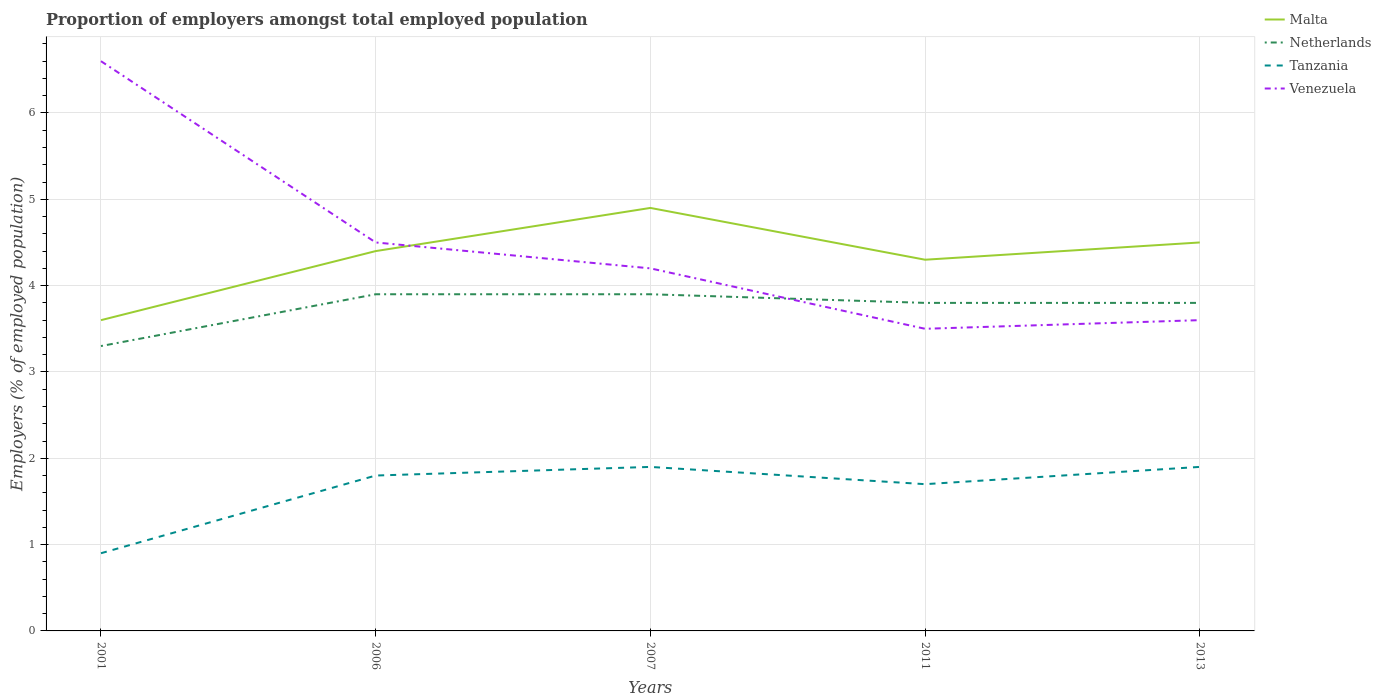How many different coloured lines are there?
Give a very brief answer. 4. Does the line corresponding to Netherlands intersect with the line corresponding to Venezuela?
Your answer should be compact. Yes. Is the number of lines equal to the number of legend labels?
Give a very brief answer. Yes. Across all years, what is the maximum proportion of employers in Malta?
Your response must be concise. 3.6. In which year was the proportion of employers in Netherlands maximum?
Give a very brief answer. 2001. What is the total proportion of employers in Netherlands in the graph?
Your response must be concise. 0.1. What is the difference between the highest and the second highest proportion of employers in Malta?
Make the answer very short. 1.3. What is the difference between the highest and the lowest proportion of employers in Malta?
Your response must be concise. 3. Is the proportion of employers in Tanzania strictly greater than the proportion of employers in Netherlands over the years?
Offer a very short reply. Yes. How many lines are there?
Your answer should be very brief. 4. What is the difference between two consecutive major ticks on the Y-axis?
Your answer should be compact. 1. Does the graph contain any zero values?
Offer a terse response. No. Does the graph contain grids?
Your answer should be compact. Yes. How many legend labels are there?
Ensure brevity in your answer.  4. How are the legend labels stacked?
Your answer should be compact. Vertical. What is the title of the graph?
Give a very brief answer. Proportion of employers amongst total employed population. What is the label or title of the Y-axis?
Offer a terse response. Employers (% of employed population). What is the Employers (% of employed population) of Malta in 2001?
Ensure brevity in your answer.  3.6. What is the Employers (% of employed population) of Netherlands in 2001?
Provide a succinct answer. 3.3. What is the Employers (% of employed population) of Tanzania in 2001?
Keep it short and to the point. 0.9. What is the Employers (% of employed population) of Venezuela in 2001?
Ensure brevity in your answer.  6.6. What is the Employers (% of employed population) in Malta in 2006?
Make the answer very short. 4.4. What is the Employers (% of employed population) in Netherlands in 2006?
Keep it short and to the point. 3.9. What is the Employers (% of employed population) of Tanzania in 2006?
Ensure brevity in your answer.  1.8. What is the Employers (% of employed population) in Malta in 2007?
Make the answer very short. 4.9. What is the Employers (% of employed population) of Netherlands in 2007?
Offer a very short reply. 3.9. What is the Employers (% of employed population) in Tanzania in 2007?
Ensure brevity in your answer.  1.9. What is the Employers (% of employed population) in Venezuela in 2007?
Provide a succinct answer. 4.2. What is the Employers (% of employed population) of Malta in 2011?
Your answer should be compact. 4.3. What is the Employers (% of employed population) in Netherlands in 2011?
Provide a succinct answer. 3.8. What is the Employers (% of employed population) of Tanzania in 2011?
Provide a succinct answer. 1.7. What is the Employers (% of employed population) of Venezuela in 2011?
Make the answer very short. 3.5. What is the Employers (% of employed population) of Netherlands in 2013?
Make the answer very short. 3.8. What is the Employers (% of employed population) of Tanzania in 2013?
Offer a very short reply. 1.9. What is the Employers (% of employed population) in Venezuela in 2013?
Offer a terse response. 3.6. Across all years, what is the maximum Employers (% of employed population) in Malta?
Provide a short and direct response. 4.9. Across all years, what is the maximum Employers (% of employed population) in Netherlands?
Offer a very short reply. 3.9. Across all years, what is the maximum Employers (% of employed population) in Tanzania?
Your answer should be compact. 1.9. Across all years, what is the maximum Employers (% of employed population) in Venezuela?
Offer a very short reply. 6.6. Across all years, what is the minimum Employers (% of employed population) in Malta?
Offer a very short reply. 3.6. Across all years, what is the minimum Employers (% of employed population) of Netherlands?
Your response must be concise. 3.3. Across all years, what is the minimum Employers (% of employed population) of Tanzania?
Provide a succinct answer. 0.9. Across all years, what is the minimum Employers (% of employed population) in Venezuela?
Give a very brief answer. 3.5. What is the total Employers (% of employed population) in Malta in the graph?
Offer a very short reply. 21.7. What is the total Employers (% of employed population) of Netherlands in the graph?
Offer a terse response. 18.7. What is the total Employers (% of employed population) of Venezuela in the graph?
Provide a succinct answer. 22.4. What is the difference between the Employers (% of employed population) in Tanzania in 2001 and that in 2006?
Your answer should be very brief. -0.9. What is the difference between the Employers (% of employed population) in Venezuela in 2001 and that in 2011?
Offer a very short reply. 3.1. What is the difference between the Employers (% of employed population) in Netherlands in 2001 and that in 2013?
Give a very brief answer. -0.5. What is the difference between the Employers (% of employed population) in Venezuela in 2001 and that in 2013?
Give a very brief answer. 3. What is the difference between the Employers (% of employed population) in Netherlands in 2006 and that in 2007?
Your answer should be compact. 0. What is the difference between the Employers (% of employed population) of Venezuela in 2006 and that in 2007?
Offer a very short reply. 0.3. What is the difference between the Employers (% of employed population) in Malta in 2006 and that in 2011?
Provide a short and direct response. 0.1. What is the difference between the Employers (% of employed population) of Netherlands in 2006 and that in 2011?
Your answer should be compact. 0.1. What is the difference between the Employers (% of employed population) in Netherlands in 2006 and that in 2013?
Provide a succinct answer. 0.1. What is the difference between the Employers (% of employed population) of Tanzania in 2006 and that in 2013?
Ensure brevity in your answer.  -0.1. What is the difference between the Employers (% of employed population) in Netherlands in 2007 and that in 2013?
Your response must be concise. 0.1. What is the difference between the Employers (% of employed population) of Venezuela in 2007 and that in 2013?
Keep it short and to the point. 0.6. What is the difference between the Employers (% of employed population) in Malta in 2011 and that in 2013?
Keep it short and to the point. -0.2. What is the difference between the Employers (% of employed population) of Tanzania in 2011 and that in 2013?
Offer a very short reply. -0.2. What is the difference between the Employers (% of employed population) in Malta in 2001 and the Employers (% of employed population) in Netherlands in 2006?
Give a very brief answer. -0.3. What is the difference between the Employers (% of employed population) in Netherlands in 2001 and the Employers (% of employed population) in Tanzania in 2006?
Offer a terse response. 1.5. What is the difference between the Employers (% of employed population) in Netherlands in 2001 and the Employers (% of employed population) in Venezuela in 2006?
Give a very brief answer. -1.2. What is the difference between the Employers (% of employed population) in Malta in 2001 and the Employers (% of employed population) in Tanzania in 2007?
Ensure brevity in your answer.  1.7. What is the difference between the Employers (% of employed population) of Malta in 2001 and the Employers (% of employed population) of Venezuela in 2007?
Your response must be concise. -0.6. What is the difference between the Employers (% of employed population) of Netherlands in 2001 and the Employers (% of employed population) of Tanzania in 2007?
Offer a very short reply. 1.4. What is the difference between the Employers (% of employed population) of Malta in 2001 and the Employers (% of employed population) of Tanzania in 2011?
Offer a very short reply. 1.9. What is the difference between the Employers (% of employed population) in Malta in 2001 and the Employers (% of employed population) in Venezuela in 2011?
Keep it short and to the point. 0.1. What is the difference between the Employers (% of employed population) of Netherlands in 2001 and the Employers (% of employed population) of Venezuela in 2011?
Make the answer very short. -0.2. What is the difference between the Employers (% of employed population) in Tanzania in 2001 and the Employers (% of employed population) in Venezuela in 2011?
Offer a very short reply. -2.6. What is the difference between the Employers (% of employed population) in Malta in 2001 and the Employers (% of employed population) in Netherlands in 2013?
Offer a terse response. -0.2. What is the difference between the Employers (% of employed population) of Malta in 2001 and the Employers (% of employed population) of Venezuela in 2013?
Ensure brevity in your answer.  0. What is the difference between the Employers (% of employed population) of Netherlands in 2001 and the Employers (% of employed population) of Venezuela in 2013?
Give a very brief answer. -0.3. What is the difference between the Employers (% of employed population) in Tanzania in 2001 and the Employers (% of employed population) in Venezuela in 2013?
Offer a very short reply. -2.7. What is the difference between the Employers (% of employed population) of Malta in 2006 and the Employers (% of employed population) of Netherlands in 2007?
Your response must be concise. 0.5. What is the difference between the Employers (% of employed population) of Malta in 2006 and the Employers (% of employed population) of Tanzania in 2011?
Make the answer very short. 2.7. What is the difference between the Employers (% of employed population) in Malta in 2006 and the Employers (% of employed population) in Venezuela in 2011?
Make the answer very short. 0.9. What is the difference between the Employers (% of employed population) in Netherlands in 2006 and the Employers (% of employed population) in Tanzania in 2011?
Your response must be concise. 2.2. What is the difference between the Employers (% of employed population) in Netherlands in 2006 and the Employers (% of employed population) in Venezuela in 2011?
Offer a very short reply. 0.4. What is the difference between the Employers (% of employed population) of Malta in 2006 and the Employers (% of employed population) of Netherlands in 2013?
Provide a short and direct response. 0.6. What is the difference between the Employers (% of employed population) in Malta in 2006 and the Employers (% of employed population) in Tanzania in 2013?
Your answer should be compact. 2.5. What is the difference between the Employers (% of employed population) of Malta in 2006 and the Employers (% of employed population) of Venezuela in 2013?
Make the answer very short. 0.8. What is the difference between the Employers (% of employed population) of Malta in 2007 and the Employers (% of employed population) of Netherlands in 2011?
Make the answer very short. 1.1. What is the difference between the Employers (% of employed population) of Malta in 2007 and the Employers (% of employed population) of Tanzania in 2011?
Your answer should be very brief. 3.2. What is the difference between the Employers (% of employed population) in Netherlands in 2007 and the Employers (% of employed population) in Tanzania in 2011?
Provide a succinct answer. 2.2. What is the difference between the Employers (% of employed population) of Netherlands in 2007 and the Employers (% of employed population) of Venezuela in 2011?
Offer a terse response. 0.4. What is the difference between the Employers (% of employed population) of Malta in 2007 and the Employers (% of employed population) of Tanzania in 2013?
Make the answer very short. 3. What is the difference between the Employers (% of employed population) of Netherlands in 2007 and the Employers (% of employed population) of Tanzania in 2013?
Make the answer very short. 2. What is the difference between the Employers (% of employed population) of Tanzania in 2007 and the Employers (% of employed population) of Venezuela in 2013?
Give a very brief answer. -1.7. What is the difference between the Employers (% of employed population) in Malta in 2011 and the Employers (% of employed population) in Netherlands in 2013?
Your answer should be very brief. 0.5. What is the difference between the Employers (% of employed population) of Malta in 2011 and the Employers (% of employed population) of Venezuela in 2013?
Your answer should be compact. 0.7. What is the difference between the Employers (% of employed population) of Netherlands in 2011 and the Employers (% of employed population) of Venezuela in 2013?
Provide a succinct answer. 0.2. What is the average Employers (% of employed population) in Malta per year?
Give a very brief answer. 4.34. What is the average Employers (% of employed population) of Netherlands per year?
Offer a terse response. 3.74. What is the average Employers (% of employed population) of Tanzania per year?
Give a very brief answer. 1.64. What is the average Employers (% of employed population) of Venezuela per year?
Ensure brevity in your answer.  4.48. In the year 2001, what is the difference between the Employers (% of employed population) in Malta and Employers (% of employed population) in Tanzania?
Ensure brevity in your answer.  2.7. In the year 2001, what is the difference between the Employers (% of employed population) of Malta and Employers (% of employed population) of Venezuela?
Your answer should be very brief. -3. In the year 2001, what is the difference between the Employers (% of employed population) in Netherlands and Employers (% of employed population) in Tanzania?
Provide a short and direct response. 2.4. In the year 2001, what is the difference between the Employers (% of employed population) in Tanzania and Employers (% of employed population) in Venezuela?
Provide a succinct answer. -5.7. In the year 2006, what is the difference between the Employers (% of employed population) of Malta and Employers (% of employed population) of Netherlands?
Your answer should be compact. 0.5. In the year 2006, what is the difference between the Employers (% of employed population) of Malta and Employers (% of employed population) of Tanzania?
Your response must be concise. 2.6. In the year 2006, what is the difference between the Employers (% of employed population) of Tanzania and Employers (% of employed population) of Venezuela?
Your answer should be compact. -2.7. In the year 2007, what is the difference between the Employers (% of employed population) of Malta and Employers (% of employed population) of Netherlands?
Your answer should be compact. 1. In the year 2007, what is the difference between the Employers (% of employed population) in Malta and Employers (% of employed population) in Tanzania?
Your answer should be compact. 3. In the year 2007, what is the difference between the Employers (% of employed population) in Malta and Employers (% of employed population) in Venezuela?
Give a very brief answer. 0.7. In the year 2007, what is the difference between the Employers (% of employed population) in Netherlands and Employers (% of employed population) in Venezuela?
Provide a succinct answer. -0.3. In the year 2011, what is the difference between the Employers (% of employed population) in Malta and Employers (% of employed population) in Venezuela?
Make the answer very short. 0.8. In the year 2011, what is the difference between the Employers (% of employed population) in Netherlands and Employers (% of employed population) in Venezuela?
Provide a short and direct response. 0.3. In the year 2013, what is the difference between the Employers (% of employed population) in Malta and Employers (% of employed population) in Tanzania?
Your answer should be very brief. 2.6. In the year 2013, what is the difference between the Employers (% of employed population) in Netherlands and Employers (% of employed population) in Venezuela?
Your answer should be compact. 0.2. In the year 2013, what is the difference between the Employers (% of employed population) in Tanzania and Employers (% of employed population) in Venezuela?
Your response must be concise. -1.7. What is the ratio of the Employers (% of employed population) in Malta in 2001 to that in 2006?
Provide a succinct answer. 0.82. What is the ratio of the Employers (% of employed population) of Netherlands in 2001 to that in 2006?
Give a very brief answer. 0.85. What is the ratio of the Employers (% of employed population) of Venezuela in 2001 to that in 2006?
Your response must be concise. 1.47. What is the ratio of the Employers (% of employed population) of Malta in 2001 to that in 2007?
Your answer should be compact. 0.73. What is the ratio of the Employers (% of employed population) of Netherlands in 2001 to that in 2007?
Offer a very short reply. 0.85. What is the ratio of the Employers (% of employed population) of Tanzania in 2001 to that in 2007?
Offer a very short reply. 0.47. What is the ratio of the Employers (% of employed population) in Venezuela in 2001 to that in 2007?
Your answer should be very brief. 1.57. What is the ratio of the Employers (% of employed population) in Malta in 2001 to that in 2011?
Provide a succinct answer. 0.84. What is the ratio of the Employers (% of employed population) of Netherlands in 2001 to that in 2011?
Offer a very short reply. 0.87. What is the ratio of the Employers (% of employed population) of Tanzania in 2001 to that in 2011?
Provide a succinct answer. 0.53. What is the ratio of the Employers (% of employed population) of Venezuela in 2001 to that in 2011?
Make the answer very short. 1.89. What is the ratio of the Employers (% of employed population) of Netherlands in 2001 to that in 2013?
Keep it short and to the point. 0.87. What is the ratio of the Employers (% of employed population) of Tanzania in 2001 to that in 2013?
Make the answer very short. 0.47. What is the ratio of the Employers (% of employed population) in Venezuela in 2001 to that in 2013?
Offer a very short reply. 1.83. What is the ratio of the Employers (% of employed population) in Malta in 2006 to that in 2007?
Offer a very short reply. 0.9. What is the ratio of the Employers (% of employed population) in Netherlands in 2006 to that in 2007?
Make the answer very short. 1. What is the ratio of the Employers (% of employed population) of Venezuela in 2006 to that in 2007?
Provide a succinct answer. 1.07. What is the ratio of the Employers (% of employed population) in Malta in 2006 to that in 2011?
Offer a terse response. 1.02. What is the ratio of the Employers (% of employed population) in Netherlands in 2006 to that in 2011?
Make the answer very short. 1.03. What is the ratio of the Employers (% of employed population) of Tanzania in 2006 to that in 2011?
Ensure brevity in your answer.  1.06. What is the ratio of the Employers (% of employed population) in Venezuela in 2006 to that in 2011?
Make the answer very short. 1.29. What is the ratio of the Employers (% of employed population) in Malta in 2006 to that in 2013?
Your answer should be very brief. 0.98. What is the ratio of the Employers (% of employed population) of Netherlands in 2006 to that in 2013?
Provide a short and direct response. 1.03. What is the ratio of the Employers (% of employed population) of Venezuela in 2006 to that in 2013?
Offer a terse response. 1.25. What is the ratio of the Employers (% of employed population) in Malta in 2007 to that in 2011?
Provide a short and direct response. 1.14. What is the ratio of the Employers (% of employed population) of Netherlands in 2007 to that in 2011?
Provide a short and direct response. 1.03. What is the ratio of the Employers (% of employed population) in Tanzania in 2007 to that in 2011?
Give a very brief answer. 1.12. What is the ratio of the Employers (% of employed population) in Venezuela in 2007 to that in 2011?
Offer a very short reply. 1.2. What is the ratio of the Employers (% of employed population) of Malta in 2007 to that in 2013?
Offer a very short reply. 1.09. What is the ratio of the Employers (% of employed population) in Netherlands in 2007 to that in 2013?
Keep it short and to the point. 1.03. What is the ratio of the Employers (% of employed population) of Venezuela in 2007 to that in 2013?
Your response must be concise. 1.17. What is the ratio of the Employers (% of employed population) of Malta in 2011 to that in 2013?
Ensure brevity in your answer.  0.96. What is the ratio of the Employers (% of employed population) of Tanzania in 2011 to that in 2013?
Offer a terse response. 0.89. What is the ratio of the Employers (% of employed population) in Venezuela in 2011 to that in 2013?
Make the answer very short. 0.97. What is the difference between the highest and the second highest Employers (% of employed population) of Malta?
Ensure brevity in your answer.  0.4. What is the difference between the highest and the second highest Employers (% of employed population) in Netherlands?
Make the answer very short. 0. What is the difference between the highest and the second highest Employers (% of employed population) of Venezuela?
Your response must be concise. 2.1. 